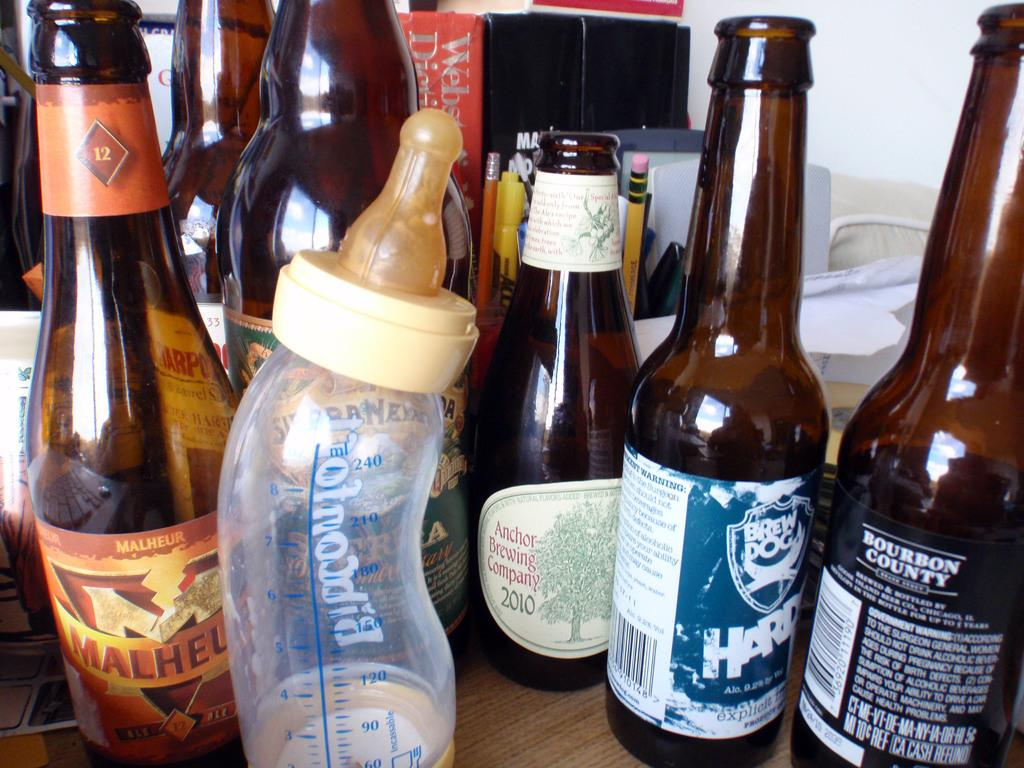<image>
Provide a brief description of the given image. A baby bottle is surrounded by alcohol bottles with one bottle with Bourbon County on it. 